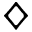<formula> <loc_0><loc_0><loc_500><loc_500>\diamondsuit</formula> 